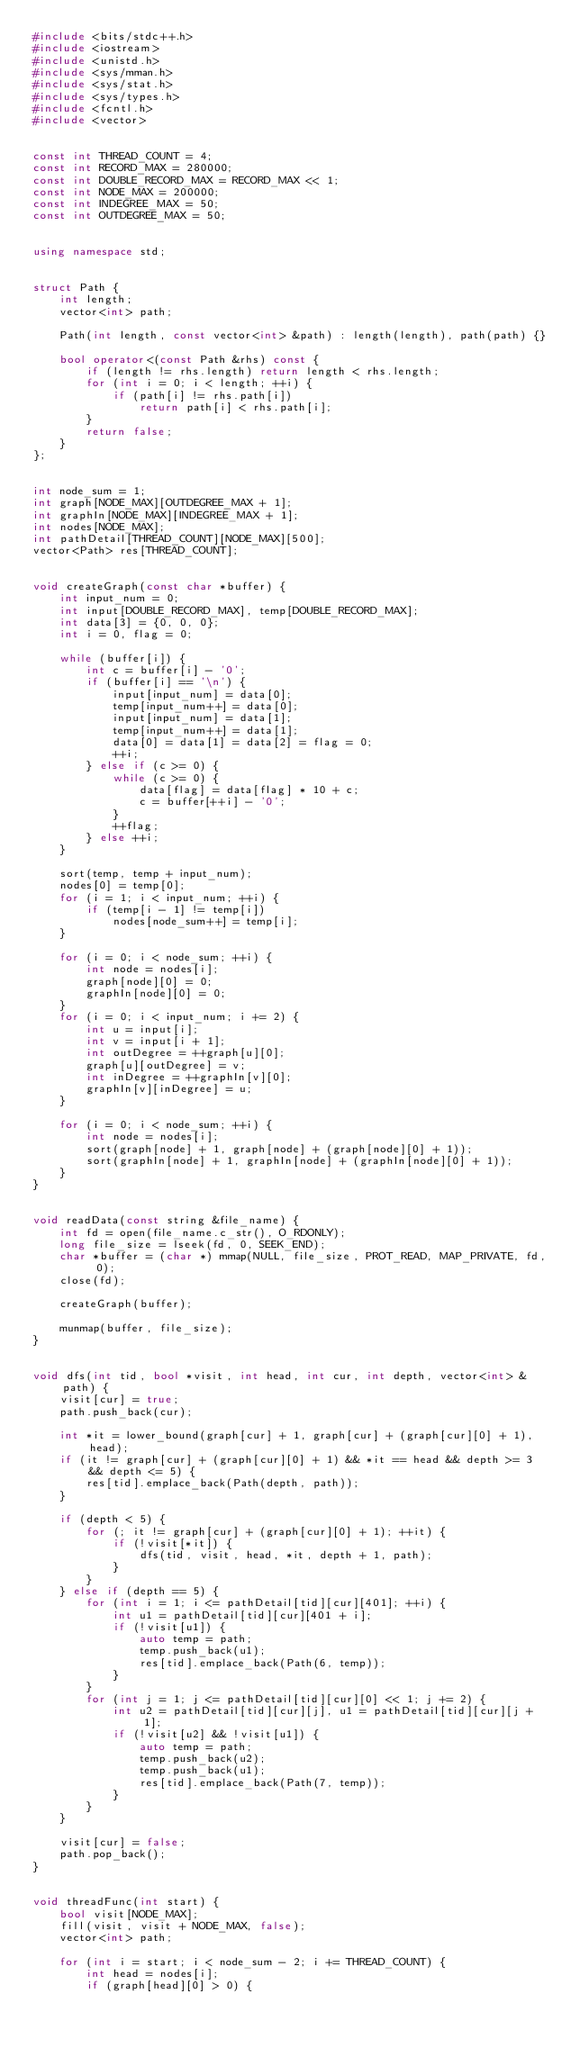<code> <loc_0><loc_0><loc_500><loc_500><_C++_>#include <bits/stdc++.h>
#include <iostream>
#include <unistd.h>
#include <sys/mman.h>
#include <sys/stat.h>
#include <sys/types.h>
#include <fcntl.h>
#include <vector>


const int THREAD_COUNT = 4;
const int RECORD_MAX = 280000;
const int DOUBLE_RECORD_MAX = RECORD_MAX << 1;
const int NODE_MAX = 200000;
const int INDEGREE_MAX = 50;
const int OUTDEGREE_MAX = 50;


using namespace std;


struct Path {
    int length;
    vector<int> path;

    Path(int length, const vector<int> &path) : length(length), path(path) {}

    bool operator<(const Path &rhs) const {
        if (length != rhs.length) return length < rhs.length;
        for (int i = 0; i < length; ++i) {
            if (path[i] != rhs.path[i])
                return path[i] < rhs.path[i];
        }
        return false;
    }
};


int node_sum = 1;
int graph[NODE_MAX][OUTDEGREE_MAX + 1];
int graphIn[NODE_MAX][INDEGREE_MAX + 1];
int nodes[NODE_MAX];
int pathDetail[THREAD_COUNT][NODE_MAX][500];
vector<Path> res[THREAD_COUNT];


void createGraph(const char *buffer) {
    int input_num = 0;
    int input[DOUBLE_RECORD_MAX], temp[DOUBLE_RECORD_MAX];
    int data[3] = {0, 0, 0};
    int i = 0, flag = 0;

    while (buffer[i]) {
        int c = buffer[i] - '0';
        if (buffer[i] == '\n') {
            input[input_num] = data[0];
            temp[input_num++] = data[0];
            input[input_num] = data[1];
            temp[input_num++] = data[1];
            data[0] = data[1] = data[2] = flag = 0;
            ++i;
        } else if (c >= 0) {
            while (c >= 0) {
                data[flag] = data[flag] * 10 + c;
                c = buffer[++i] - '0';
            }
            ++flag;
        } else ++i;
    }

    sort(temp, temp + input_num);
    nodes[0] = temp[0];
    for (i = 1; i < input_num; ++i) {
        if (temp[i - 1] != temp[i])
            nodes[node_sum++] = temp[i];
    }

    for (i = 0; i < node_sum; ++i) {
        int node = nodes[i];
        graph[node][0] = 0;
        graphIn[node][0] = 0;
    }
    for (i = 0; i < input_num; i += 2) {
        int u = input[i];
        int v = input[i + 1];
        int outDegree = ++graph[u][0];
        graph[u][outDegree] = v;
        int inDegree = ++graphIn[v][0];
        graphIn[v][inDegree] = u;
    }

    for (i = 0; i < node_sum; ++i) {
        int node = nodes[i];
        sort(graph[node] + 1, graph[node] + (graph[node][0] + 1));
        sort(graphIn[node] + 1, graphIn[node] + (graphIn[node][0] + 1));
    }
}


void readData(const string &file_name) {
    int fd = open(file_name.c_str(), O_RDONLY);
    long file_size = lseek(fd, 0, SEEK_END);
    char *buffer = (char *) mmap(NULL, file_size, PROT_READ, MAP_PRIVATE, fd, 0);
    close(fd);

    createGraph(buffer);

    munmap(buffer, file_size);
}


void dfs(int tid, bool *visit, int head, int cur, int depth, vector<int> &path) {
    visit[cur] = true;
    path.push_back(cur);

    int *it = lower_bound(graph[cur] + 1, graph[cur] + (graph[cur][0] + 1), head);
    if (it != graph[cur] + (graph[cur][0] + 1) && *it == head && depth >= 3 && depth <= 5) {
        res[tid].emplace_back(Path(depth, path));
    }

    if (depth < 5) {
        for (; it != graph[cur] + (graph[cur][0] + 1); ++it) {
            if (!visit[*it]) {
                dfs(tid, visit, head, *it, depth + 1, path);
            }
        }
    } else if (depth == 5) {
        for (int i = 1; i <= pathDetail[tid][cur][401]; ++i) {
            int u1 = pathDetail[tid][cur][401 + i];
            if (!visit[u1]) {
                auto temp = path;
                temp.push_back(u1);
                res[tid].emplace_back(Path(6, temp));
            }
        }
        for (int j = 1; j <= pathDetail[tid][cur][0] << 1; j += 2) {
            int u2 = pathDetail[tid][cur][j], u1 = pathDetail[tid][cur][j + 1];
            if (!visit[u2] && !visit[u1]) {
                auto temp = path;
                temp.push_back(u2);
                temp.push_back(u1);
                res[tid].emplace_back(Path(7, temp));
            }
        }
    }

    visit[cur] = false;
    path.pop_back();
}


void threadFunc(int start) {
    bool visit[NODE_MAX];
    fill(visit, visit + NODE_MAX, false);
    vector<int> path;

    for (int i = start; i < node_sum - 2; i += THREAD_COUNT) {
        int head = nodes[i];
        if (graph[head][0] > 0) {</code> 